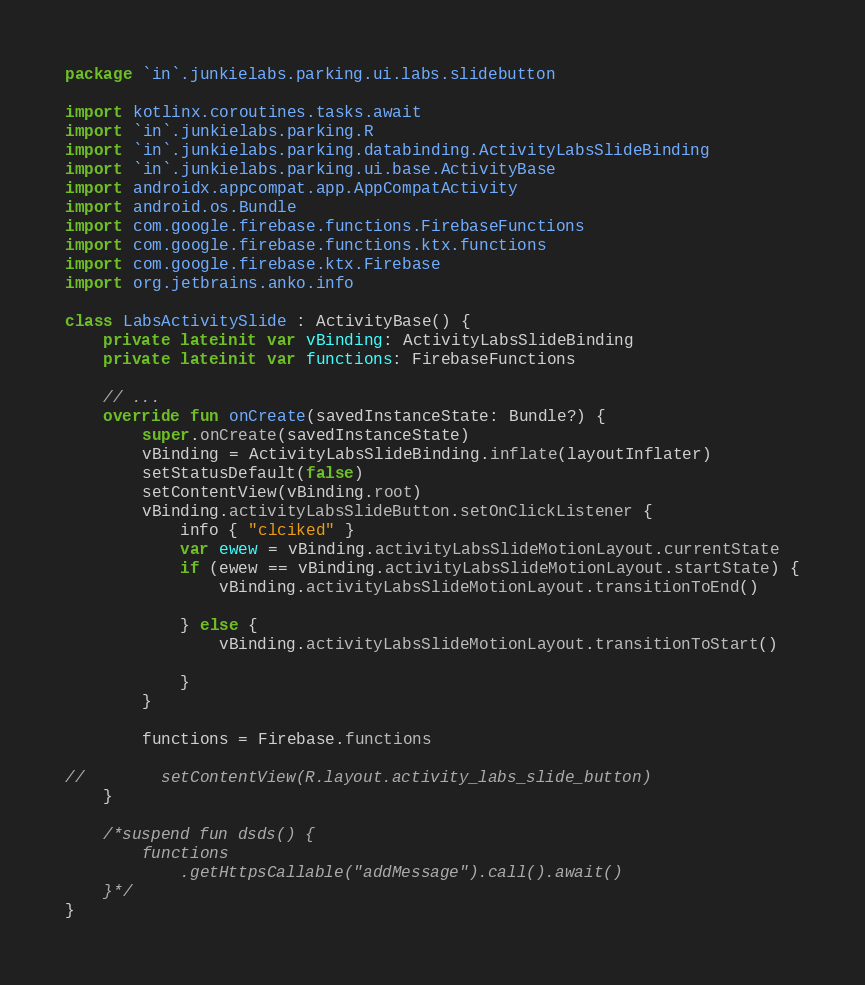Convert code to text. <code><loc_0><loc_0><loc_500><loc_500><_Kotlin_>package `in`.junkielabs.parking.ui.labs.slidebutton

import kotlinx.coroutines.tasks.await
import `in`.junkielabs.parking.R
import `in`.junkielabs.parking.databinding.ActivityLabsSlideBinding
import `in`.junkielabs.parking.ui.base.ActivityBase
import androidx.appcompat.app.AppCompatActivity
import android.os.Bundle
import com.google.firebase.functions.FirebaseFunctions
import com.google.firebase.functions.ktx.functions
import com.google.firebase.ktx.Firebase
import org.jetbrains.anko.info

class LabsActivitySlide : ActivityBase() {
    private lateinit var vBinding: ActivityLabsSlideBinding
    private lateinit var functions: FirebaseFunctions

    // ...
    override fun onCreate(savedInstanceState: Bundle?) {
        super.onCreate(savedInstanceState)
        vBinding = ActivityLabsSlideBinding.inflate(layoutInflater)
        setStatusDefault(false)
        setContentView(vBinding.root)
        vBinding.activityLabsSlideButton.setOnClickListener {
            info { "clciked" }
            var ewew = vBinding.activityLabsSlideMotionLayout.currentState
            if (ewew == vBinding.activityLabsSlideMotionLayout.startState) {
                vBinding.activityLabsSlideMotionLayout.transitionToEnd()

            } else {
                vBinding.activityLabsSlideMotionLayout.transitionToStart()

            }
        }

        functions = Firebase.functions

//        setContentView(R.layout.activity_labs_slide_button)
    }

    /*suspend fun dsds() {
        functions
            .getHttpsCallable("addMessage").call().await()
    }*/
}</code> 